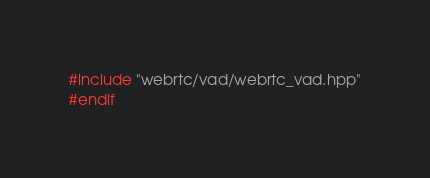Convert code to text. <code><loc_0><loc_0><loc_500><loc_500><_C++_>#include "webrtc/vad/webrtc_vad.hpp"
#endif</code> 